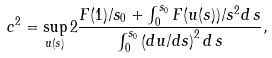<formula> <loc_0><loc_0><loc_500><loc_500>c ^ { 2 } = \sup _ { u ( s ) } 2 \frac { F ( 1 ) / s _ { 0 } + \int _ { 0 } ^ { s _ { 0 } } F ( u ( s ) ) / s ^ { 2 } d \, s } { \int _ { 0 } ^ { s _ { 0 } } \left ( d u / d s \right ) ^ { 2 } d \, s } ,</formula> 